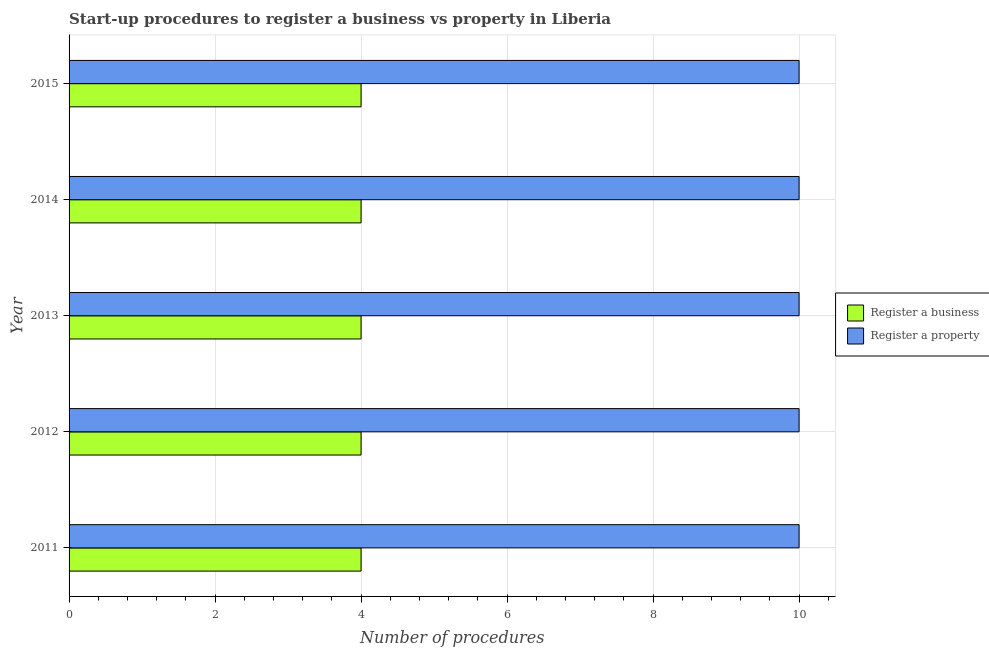How many groups of bars are there?
Your response must be concise. 5. Are the number of bars on each tick of the Y-axis equal?
Keep it short and to the point. Yes. How many bars are there on the 1st tick from the bottom?
Provide a succinct answer. 2. In how many cases, is the number of bars for a given year not equal to the number of legend labels?
Offer a very short reply. 0. What is the number of procedures to register a business in 2014?
Offer a terse response. 4. Across all years, what is the maximum number of procedures to register a property?
Your answer should be compact. 10. Across all years, what is the minimum number of procedures to register a business?
Your answer should be compact. 4. What is the total number of procedures to register a property in the graph?
Provide a short and direct response. 50. What is the difference between the number of procedures to register a business in 2011 and that in 2012?
Keep it short and to the point. 0. What is the difference between the number of procedures to register a business in 2012 and the number of procedures to register a property in 2014?
Your answer should be compact. -6. What is the average number of procedures to register a business per year?
Ensure brevity in your answer.  4. In the year 2014, what is the difference between the number of procedures to register a business and number of procedures to register a property?
Offer a terse response. -6. In how many years, is the number of procedures to register a business greater than 1.6 ?
Give a very brief answer. 5. Is the number of procedures to register a business in 2011 less than that in 2013?
Give a very brief answer. No. Is the difference between the number of procedures to register a business in 2013 and 2015 greater than the difference between the number of procedures to register a property in 2013 and 2015?
Offer a very short reply. No. What is the difference between the highest and the second highest number of procedures to register a business?
Your answer should be compact. 0. What does the 1st bar from the top in 2012 represents?
Your answer should be compact. Register a property. What does the 1st bar from the bottom in 2012 represents?
Make the answer very short. Register a business. Are the values on the major ticks of X-axis written in scientific E-notation?
Provide a short and direct response. No. Does the graph contain grids?
Give a very brief answer. Yes. How many legend labels are there?
Provide a succinct answer. 2. What is the title of the graph?
Your answer should be very brief. Start-up procedures to register a business vs property in Liberia. Does "Investments" appear as one of the legend labels in the graph?
Make the answer very short. No. What is the label or title of the X-axis?
Ensure brevity in your answer.  Number of procedures. What is the label or title of the Y-axis?
Give a very brief answer. Year. What is the Number of procedures of Register a business in 2012?
Provide a short and direct response. 4. What is the Number of procedures of Register a property in 2012?
Your answer should be very brief. 10. What is the Number of procedures in Register a business in 2014?
Your answer should be very brief. 4. What is the Number of procedures in Register a property in 2014?
Keep it short and to the point. 10. What is the Number of procedures of Register a business in 2015?
Offer a terse response. 4. Across all years, what is the maximum Number of procedures of Register a property?
Your answer should be compact. 10. Across all years, what is the minimum Number of procedures of Register a property?
Make the answer very short. 10. What is the total Number of procedures in Register a business in the graph?
Offer a terse response. 20. What is the difference between the Number of procedures of Register a business in 2011 and that in 2013?
Give a very brief answer. 0. What is the difference between the Number of procedures of Register a business in 2012 and that in 2013?
Keep it short and to the point. 0. What is the difference between the Number of procedures in Register a property in 2012 and that in 2013?
Provide a short and direct response. 0. What is the difference between the Number of procedures in Register a business in 2012 and that in 2015?
Your answer should be very brief. 0. What is the difference between the Number of procedures of Register a property in 2012 and that in 2015?
Give a very brief answer. 0. What is the difference between the Number of procedures in Register a business in 2013 and that in 2014?
Your response must be concise. 0. What is the difference between the Number of procedures of Register a property in 2013 and that in 2014?
Provide a succinct answer. 0. What is the difference between the Number of procedures of Register a business in 2013 and that in 2015?
Your answer should be compact. 0. What is the difference between the Number of procedures in Register a property in 2013 and that in 2015?
Offer a terse response. 0. What is the difference between the Number of procedures in Register a business in 2014 and that in 2015?
Provide a short and direct response. 0. What is the difference between the Number of procedures of Register a property in 2014 and that in 2015?
Your response must be concise. 0. What is the difference between the Number of procedures of Register a business in 2011 and the Number of procedures of Register a property in 2014?
Provide a succinct answer. -6. What is the difference between the Number of procedures in Register a business in 2012 and the Number of procedures in Register a property in 2015?
Your response must be concise. -6. What is the average Number of procedures in Register a property per year?
Provide a succinct answer. 10. What is the ratio of the Number of procedures in Register a property in 2011 to that in 2012?
Provide a succinct answer. 1. What is the ratio of the Number of procedures of Register a property in 2011 to that in 2013?
Your answer should be compact. 1. What is the ratio of the Number of procedures in Register a business in 2011 to that in 2014?
Your response must be concise. 1. What is the ratio of the Number of procedures of Register a business in 2011 to that in 2015?
Offer a terse response. 1. What is the ratio of the Number of procedures in Register a property in 2011 to that in 2015?
Make the answer very short. 1. What is the ratio of the Number of procedures of Register a business in 2012 to that in 2013?
Provide a succinct answer. 1. What is the ratio of the Number of procedures of Register a business in 2012 to that in 2015?
Provide a succinct answer. 1. What is the ratio of the Number of procedures of Register a business in 2013 to that in 2014?
Your response must be concise. 1. What is the ratio of the Number of procedures of Register a property in 2013 to that in 2014?
Your answer should be compact. 1. What is the ratio of the Number of procedures of Register a property in 2013 to that in 2015?
Give a very brief answer. 1. What is the ratio of the Number of procedures of Register a property in 2014 to that in 2015?
Offer a terse response. 1. What is the difference between the highest and the second highest Number of procedures in Register a business?
Your answer should be compact. 0. What is the difference between the highest and the lowest Number of procedures of Register a property?
Keep it short and to the point. 0. 